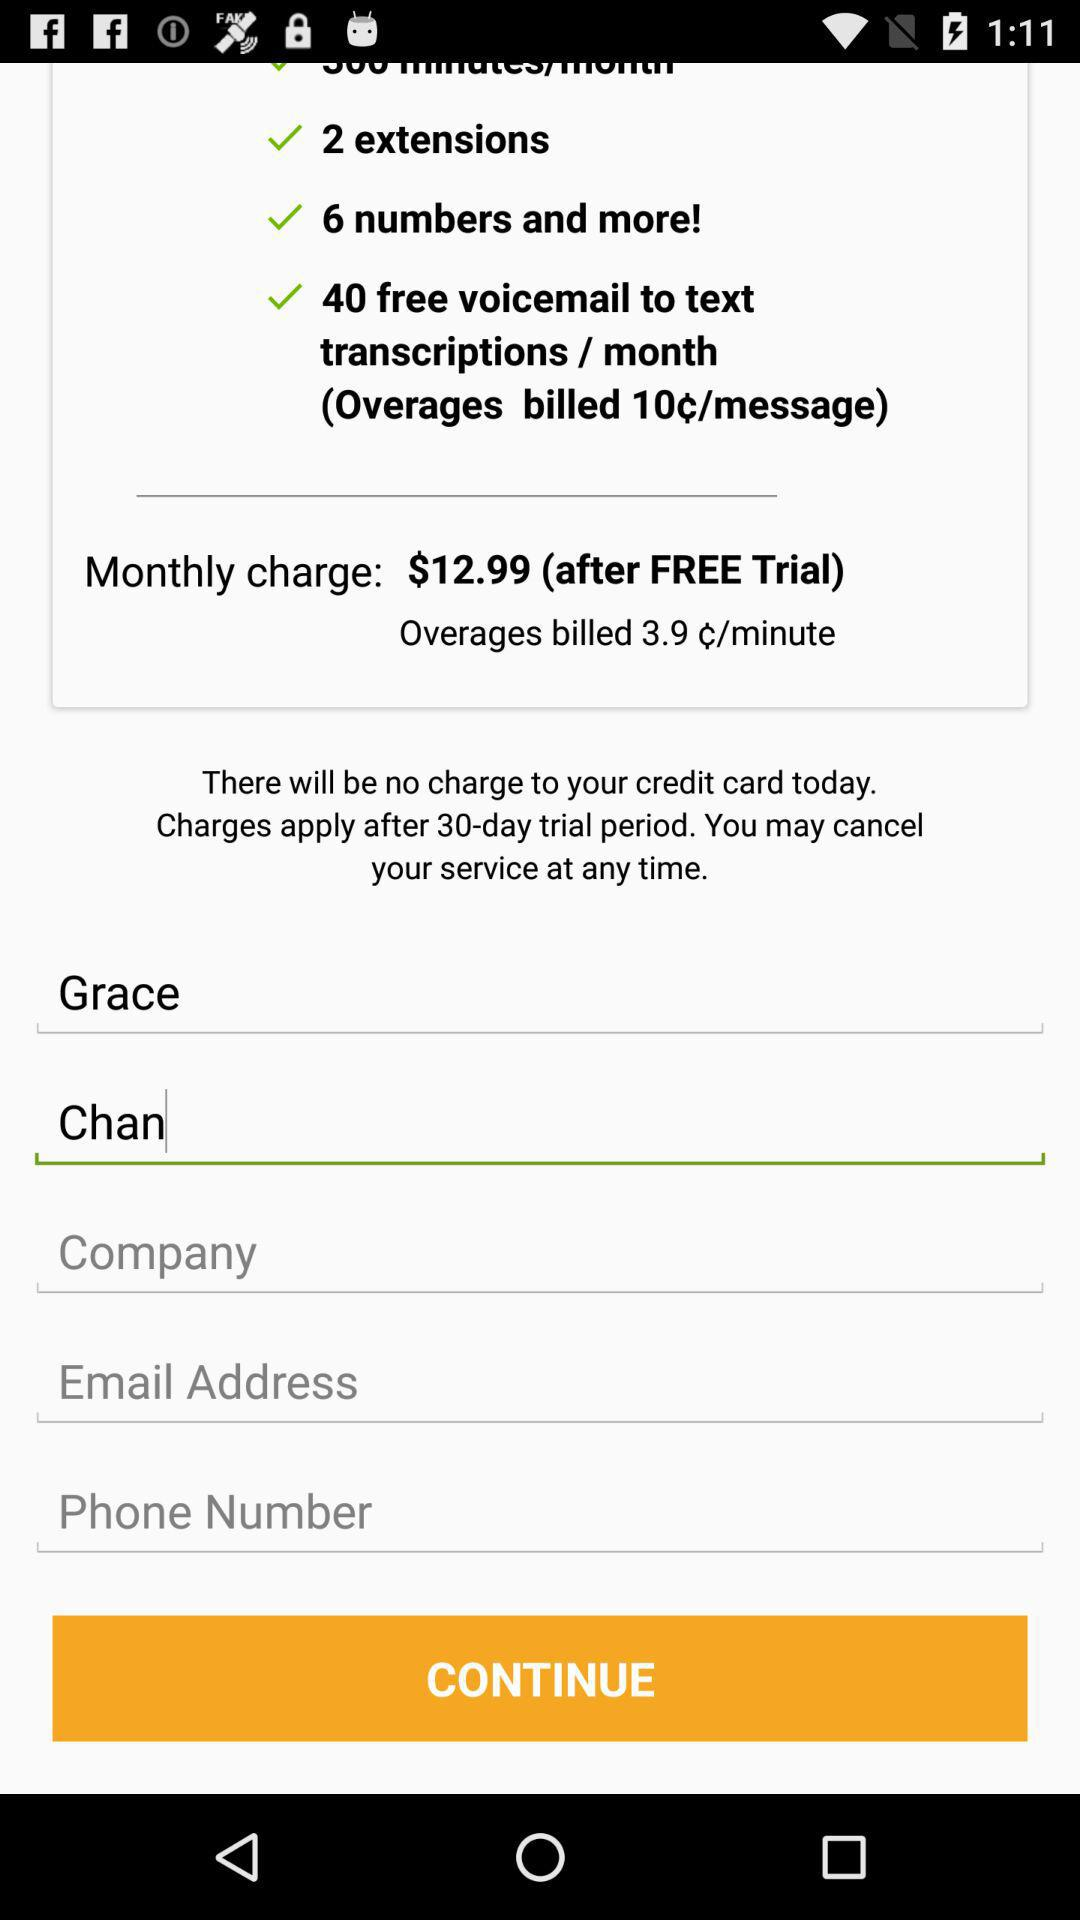After how many days do the charges apply? The charges apply after 30 days. 